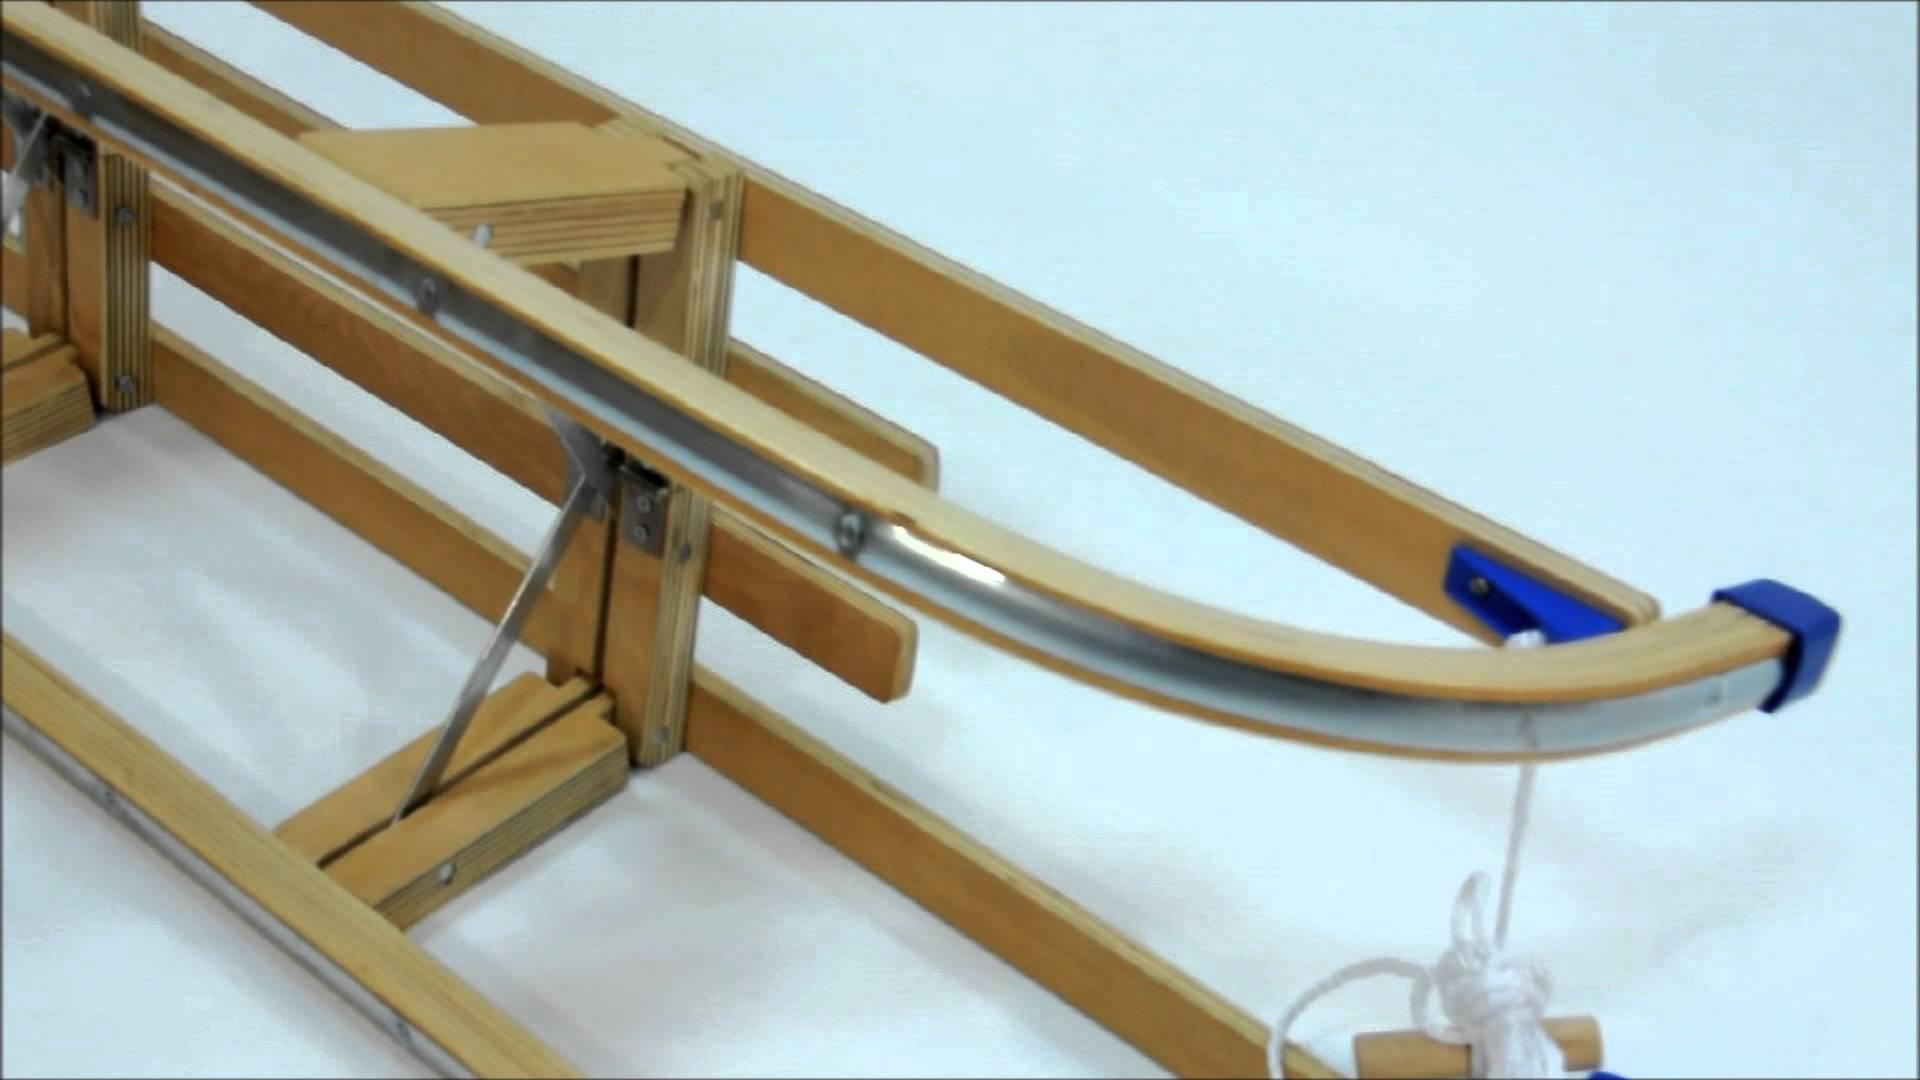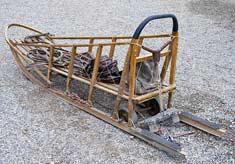The first image is the image on the left, the second image is the image on the right. Considering the images on both sides, is "The left image contains exactly one male human." valid? Answer yes or no. No. The first image is the image on the left, the second image is the image on the right. Given the left and right images, does the statement "There is a human looking at a sled in one of the images." hold true? Answer yes or no. No. 